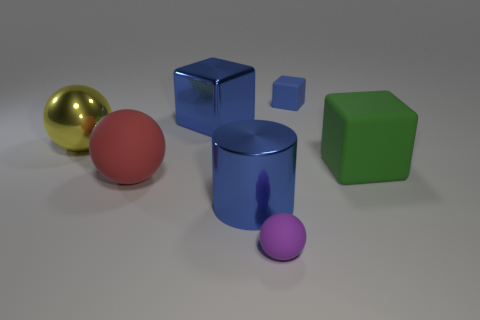There is a rubber thing that is both on the right side of the large red thing and in front of the big green thing; what color is it?
Your response must be concise. Purple. Is there a big metal cube?
Provide a succinct answer. Yes. Are there the same number of blue cylinders behind the yellow sphere and big cyan matte objects?
Your response must be concise. Yes. The tiny blue object is what shape?
Give a very brief answer. Cube. Are the purple sphere and the tiny blue block made of the same material?
Your answer should be compact. Yes. Are there the same number of balls to the right of the large green matte block and big rubber objects that are behind the red matte sphere?
Your answer should be very brief. No. Are there any blue blocks that are behind the big blue metal object behind the cube in front of the yellow shiny thing?
Give a very brief answer. Yes. Does the blue cylinder have the same size as the purple thing?
Your answer should be very brief. No. What color is the big sphere that is in front of the big matte object that is right of the large shiny thing in front of the large yellow ball?
Your answer should be very brief. Red. How many small matte things are the same color as the shiny block?
Your answer should be very brief. 1. 